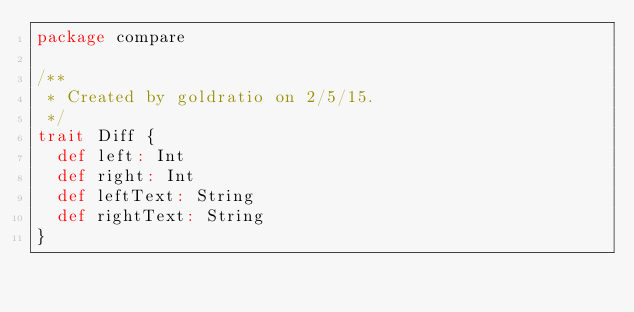<code> <loc_0><loc_0><loc_500><loc_500><_Scala_>package compare

/**
 * Created by goldratio on 2/5/15.
 */
trait Diff {
  def left: Int
  def right: Int
  def leftText: String
  def rightText: String
}
</code> 